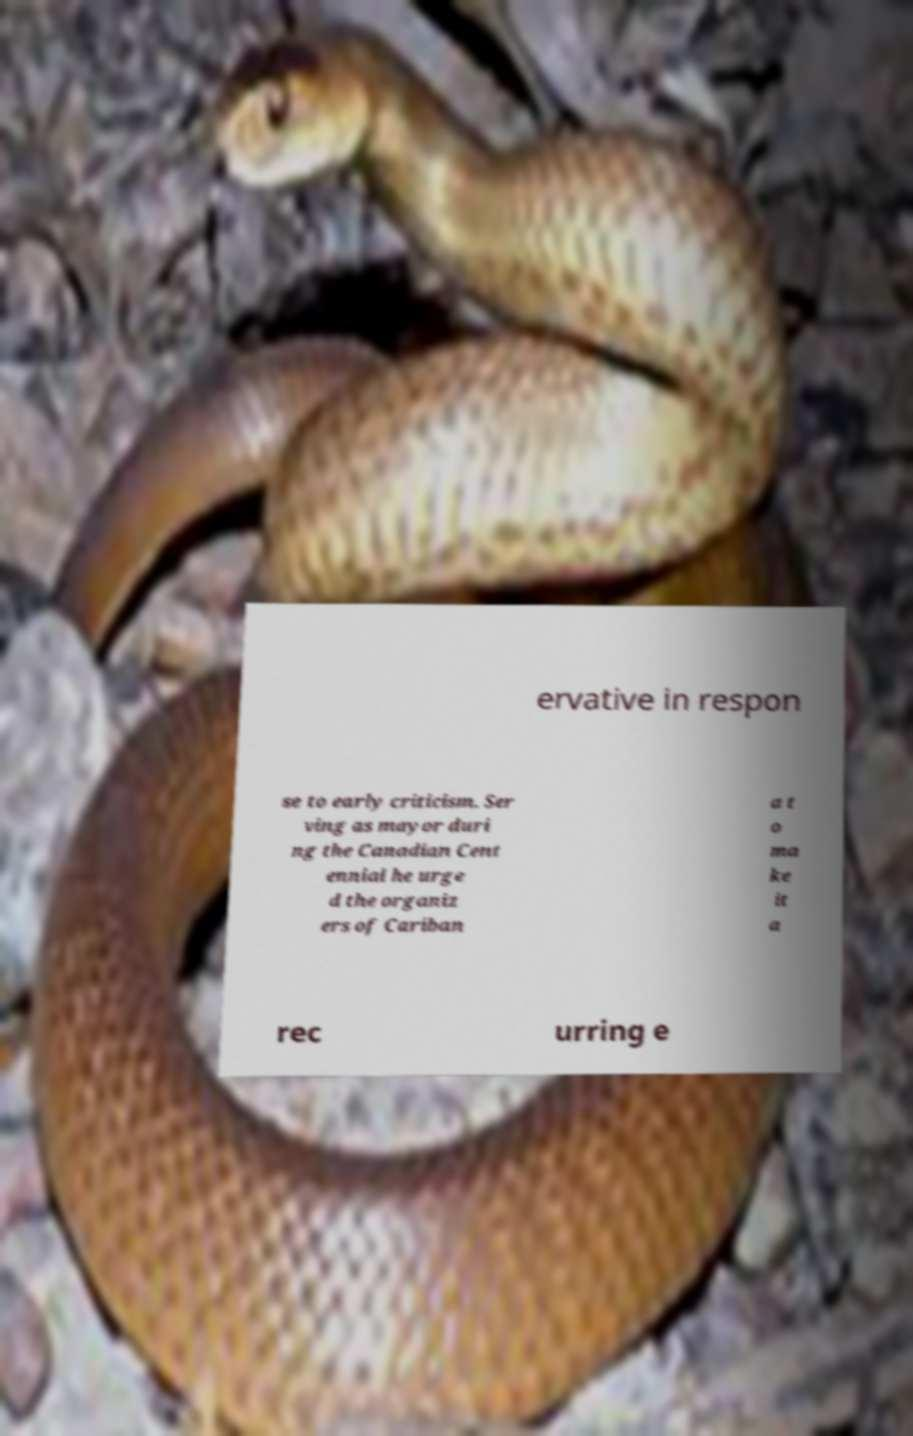Can you read and provide the text displayed in the image?This photo seems to have some interesting text. Can you extract and type it out for me? ervative in respon se to early criticism. Ser ving as mayor duri ng the Canadian Cent ennial he urge d the organiz ers of Cariban a t o ma ke it a rec urring e 